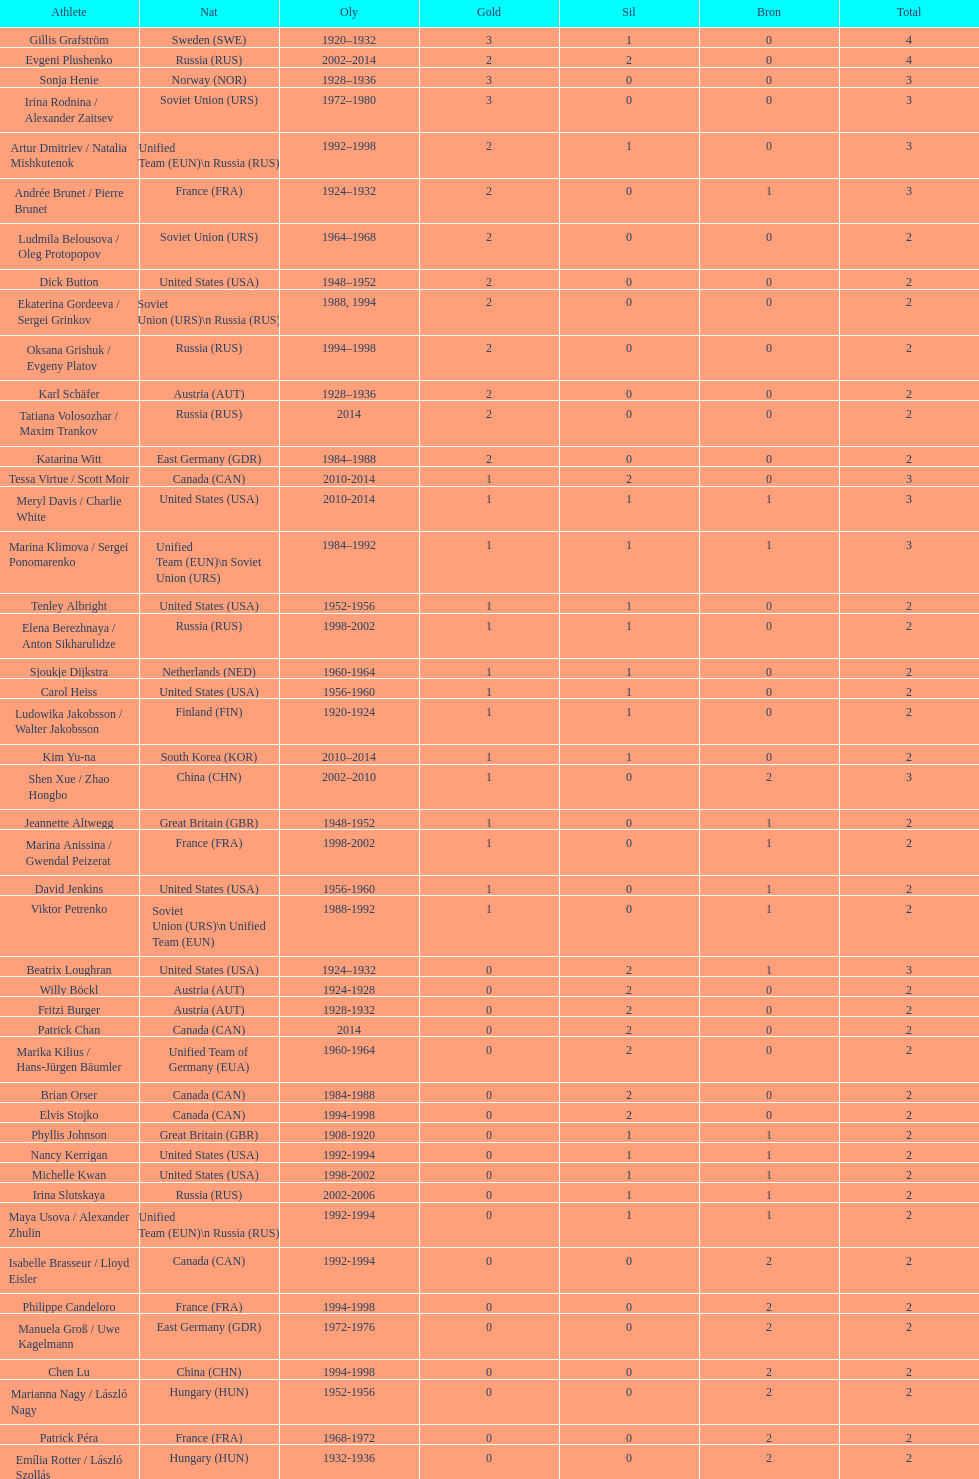How many more silver medals did gillis grafström have compared to sonja henie? 1. 